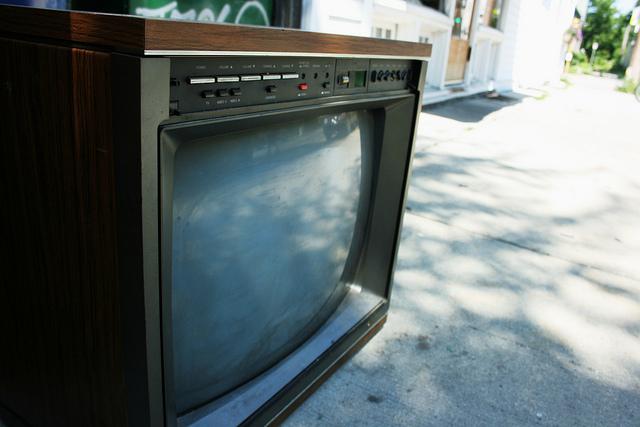IS there a brick in the picture?
Be succinct. No. How old is this TV?
Give a very brief answer. Old. Is this TV upside-down?
Quick response, please. Yes. What object is this?
Write a very short answer. Television. 